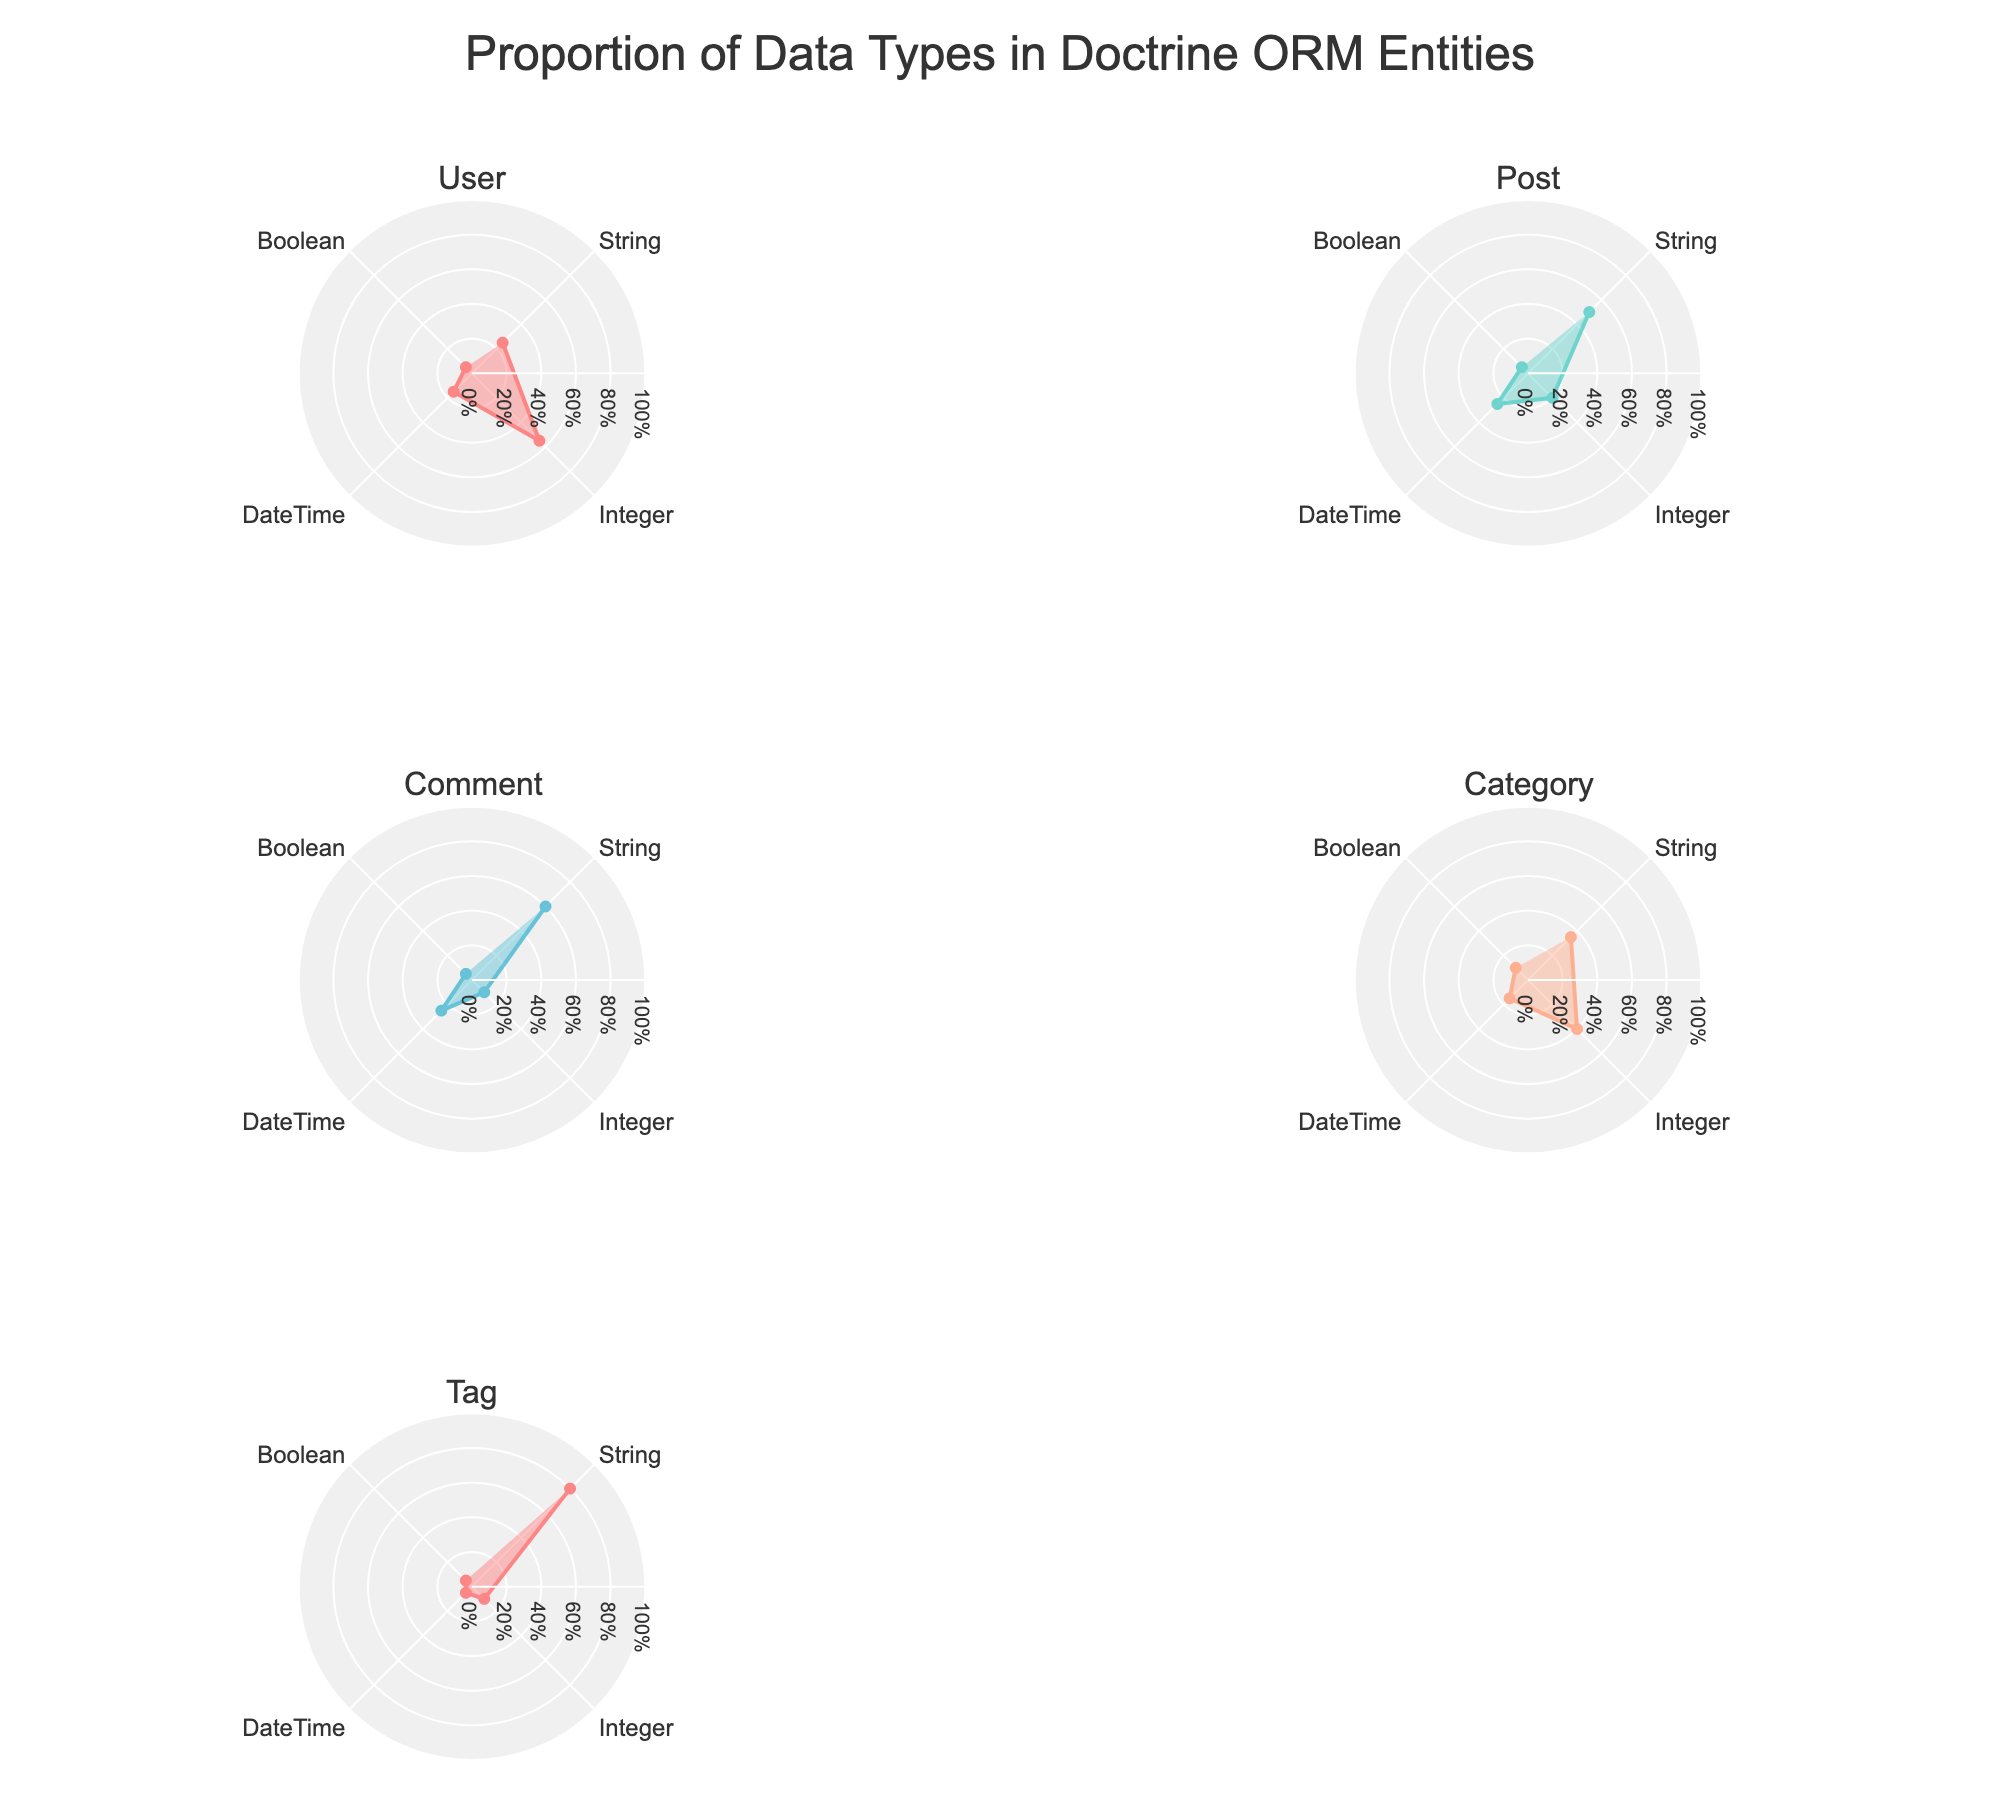What is the title of the figure? The title is usually located at the top of the figure. In this case, the title is clearly mentioned.
Answer: Proportion of Data Types in Doctrine ORM Entities How many entities are represented in the figure? Count the subplot titles, each representing a unique entity.
Answer: 5 Which entity has the highest proportion of String data type? Observe the String proportion for each entity and identify the highest. The Tag entity has the highest String proportion.
Answer: Tag What is the proportion of Integer data type for the Post entity? Locate the Post entity subplot and check the Integer data type segment.
Answer: 0.2 Which entity has the smallest proportion of Boolean data type? Compare the Boolean proportions across all entities. All entities have the same proportion of Boolean data type, which is 0.05.
Answer: User, Post, Comment, Category, Tag Compare the proportion of DateTime data type between User and Category entities. Which has a higher proportion? Look at the DateTime segments for User and Category subplots. User has 0.15 and Category also has 0.15. They are equal.
Answer: Equal Add the proportions of String and Integer data types for the Comment entity. What is the result? Sum the String (0.6) and Integer (0.1) proportions for the Comment entity. 0.6 + 0.1 = 0.7.
Answer: 0.7 What proportion of data types for the User entity fall under non-String categories? Sum the proportions of Integer, DateTime, and Boolean for User. 0.55 + 0.15 + 0.05 = 0.75.
Answer: 0.75 Which entity has the highest diversity in data type proportions? Identify the entity where the proportions of data types are most varied. Comment entity shows varied distribution with significant proportions in String, DateTime, and Integer.
Answer: Comment What is the combined proportion of String and DateTime data types for the Tag entity? Sum the String (0.8) and DateTime (0.05) proportions for Tag. 0.8 + 0.05 = 0.85.
Answer: 0.85 Summing up the Integer and Boolean proportions, which entity has the smallest combined proportion and what is it? Sum Integer and Boolean for each entity, find the smallest sum. Tag has 0.1 + 0.05 = 0.15, which is the smallest.
Answer: Tag, 0.15 